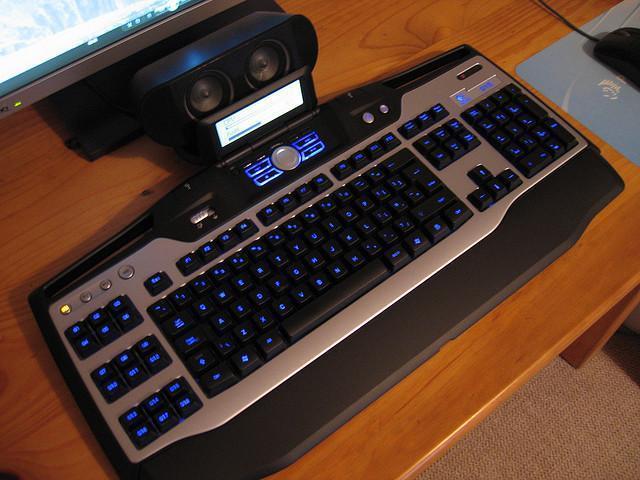How many tvs are in the photo?
Give a very brief answer. 1. 